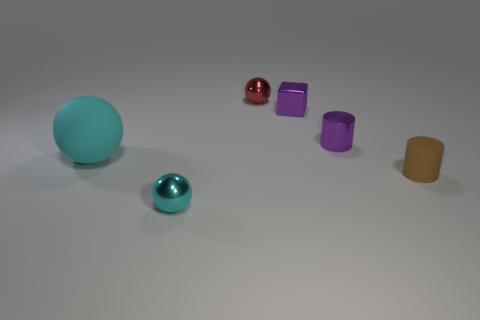Subtract all big cyan rubber spheres. How many spheres are left? 2 Add 2 brown metallic things. How many objects exist? 8 Subtract all red spheres. How many spheres are left? 2 Subtract all cubes. How many objects are left? 5 Subtract all blue cylinders. How many cyan balls are left? 2 Add 1 tiny brown rubber cylinders. How many tiny brown rubber cylinders are left? 2 Add 2 tiny red metal things. How many tiny red metal things exist? 3 Subtract 0 green cubes. How many objects are left? 6 Subtract 2 balls. How many balls are left? 1 Subtract all blue cylinders. Subtract all blue balls. How many cylinders are left? 2 